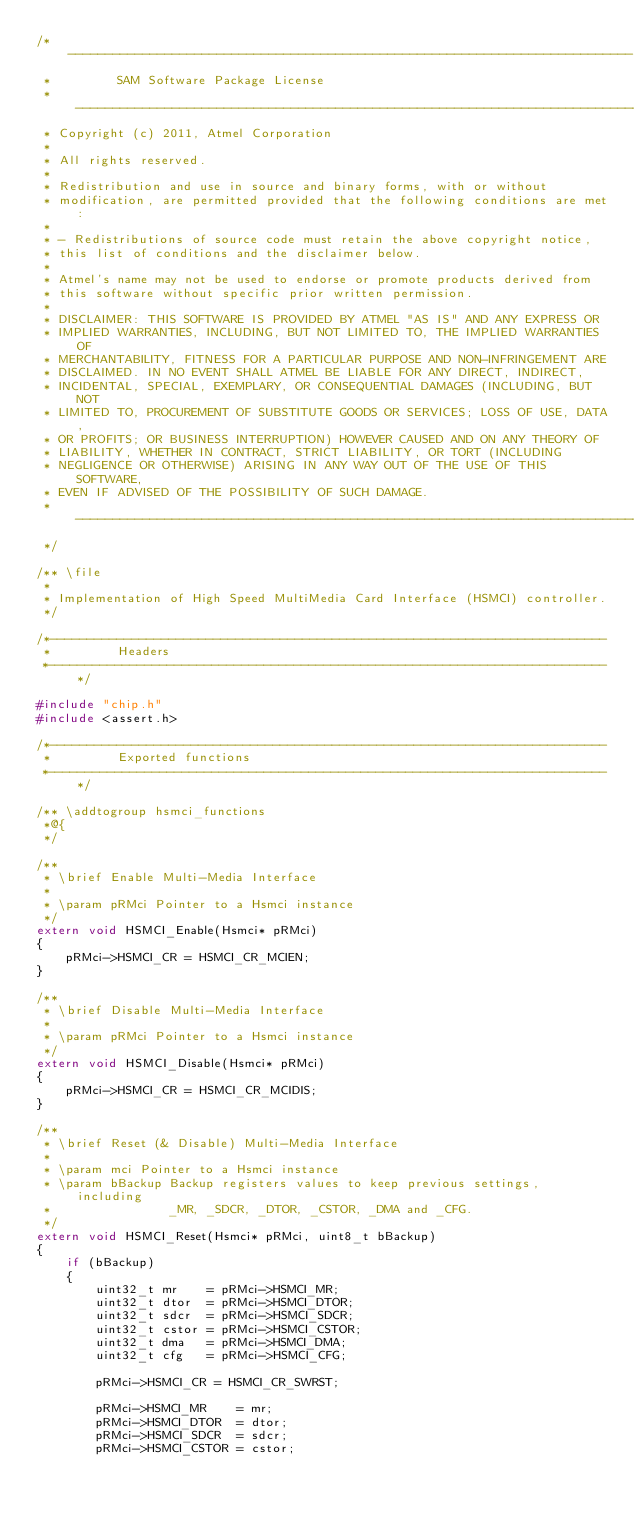Convert code to text. <code><loc_0><loc_0><loc_500><loc_500><_C_>/* ----------------------------------------------------------------------------
 *         SAM Software Package License 
 * ----------------------------------------------------------------------------
 * Copyright (c) 2011, Atmel Corporation
 *
 * All rights reserved.
 *
 * Redistribution and use in source and binary forms, with or without
 * modification, are permitted provided that the following conditions are met:
 *
 * - Redistributions of source code must retain the above copyright notice,
 * this list of conditions and the disclaimer below.
 *
 * Atmel's name may not be used to endorse or promote products derived from
 * this software without specific prior written permission.
 *
 * DISCLAIMER: THIS SOFTWARE IS PROVIDED BY ATMEL "AS IS" AND ANY EXPRESS OR
 * IMPLIED WARRANTIES, INCLUDING, BUT NOT LIMITED TO, THE IMPLIED WARRANTIES OF
 * MERCHANTABILITY, FITNESS FOR A PARTICULAR PURPOSE AND NON-INFRINGEMENT ARE
 * DISCLAIMED. IN NO EVENT SHALL ATMEL BE LIABLE FOR ANY DIRECT, INDIRECT,
 * INCIDENTAL, SPECIAL, EXEMPLARY, OR CONSEQUENTIAL DAMAGES (INCLUDING, BUT NOT
 * LIMITED TO, PROCUREMENT OF SUBSTITUTE GOODS OR SERVICES; LOSS OF USE, DATA,
 * OR PROFITS; OR BUSINESS INTERRUPTION) HOWEVER CAUSED AND ON ANY THEORY OF
 * LIABILITY, WHETHER IN CONTRACT, STRICT LIABILITY, OR TORT (INCLUDING
 * NEGLIGENCE OR OTHERWISE) ARISING IN ANY WAY OUT OF THE USE OF THIS SOFTWARE,
 * EVEN IF ADVISED OF THE POSSIBILITY OF SUCH DAMAGE.
 * ----------------------------------------------------------------------------
 */

/** \file
 *
 * Implementation of High Speed MultiMedia Card Interface (HSMCI) controller.
 */

/*---------------------------------------------------------------------------
 *         Headers
 *---------------------------------------------------------------------------*/

#include "chip.h"
#include <assert.h>

/*---------------------------------------------------------------------------
 *         Exported functions
 *---------------------------------------------------------------------------*/

/** \addtogroup hsmci_functions
 *@{
 */

/**
 * \brief Enable Multi-Media Interface
 *
 * \param pRMci Pointer to a Hsmci instance
 */
extern void HSMCI_Enable(Hsmci* pRMci)
{
    pRMci->HSMCI_CR = HSMCI_CR_MCIEN;
}

/**
 * \brief Disable Multi-Media Interface
 *
 * \param pRMci Pointer to a Hsmci instance
 */
extern void HSMCI_Disable(Hsmci* pRMci)
{
    pRMci->HSMCI_CR = HSMCI_CR_MCIDIS;
}

/**
 * \brief Reset (& Disable) Multi-Media Interface
 *
 * \param mci Pointer to a Hsmci instance
 * \param bBackup Backup registers values to keep previous settings, including
 *                _MR, _SDCR, _DTOR, _CSTOR, _DMA and _CFG.
 */
extern void HSMCI_Reset(Hsmci* pRMci, uint8_t bBackup)
{
    if (bBackup)
    {
        uint32_t mr    = pRMci->HSMCI_MR;
        uint32_t dtor  = pRMci->HSMCI_DTOR;
        uint32_t sdcr  = pRMci->HSMCI_SDCR;
        uint32_t cstor = pRMci->HSMCI_CSTOR;
        uint32_t dma   = pRMci->HSMCI_DMA;
        uint32_t cfg   = pRMci->HSMCI_CFG;

        pRMci->HSMCI_CR = HSMCI_CR_SWRST;

        pRMci->HSMCI_MR    = mr;
        pRMci->HSMCI_DTOR  = dtor;
        pRMci->HSMCI_SDCR  = sdcr;
        pRMci->HSMCI_CSTOR = cstor;</code> 